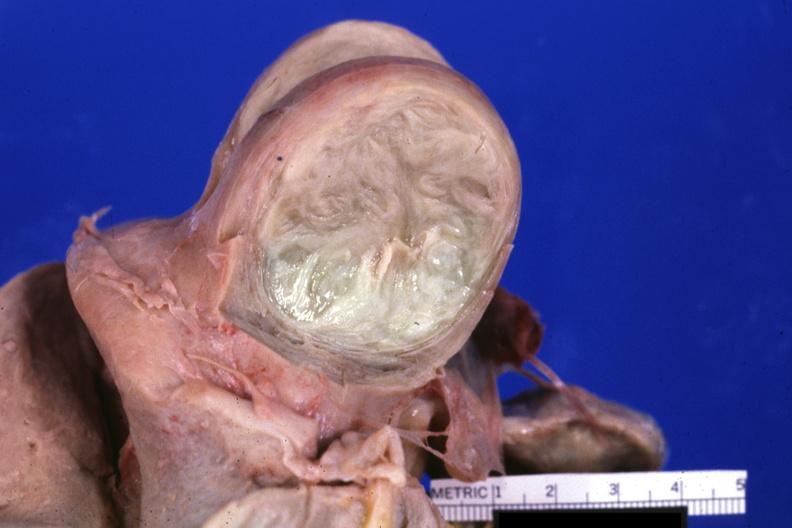what is present?
Answer the question using a single word or phrase. Female reproductive 